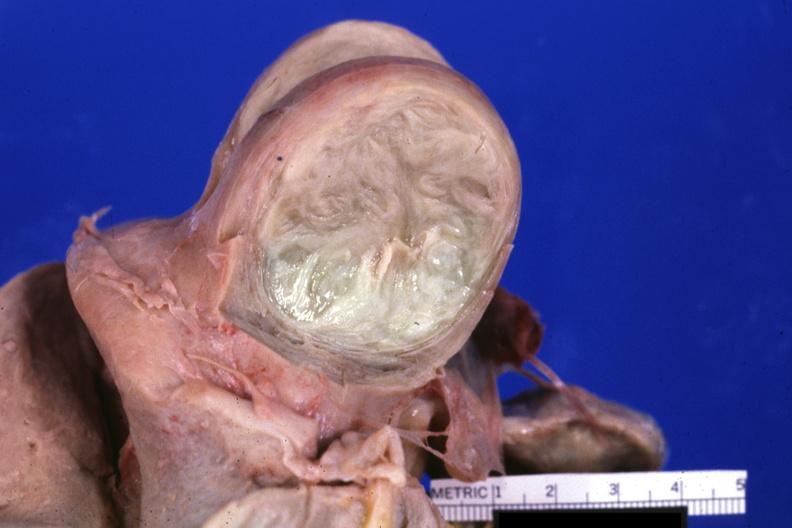what is present?
Answer the question using a single word or phrase. Female reproductive 